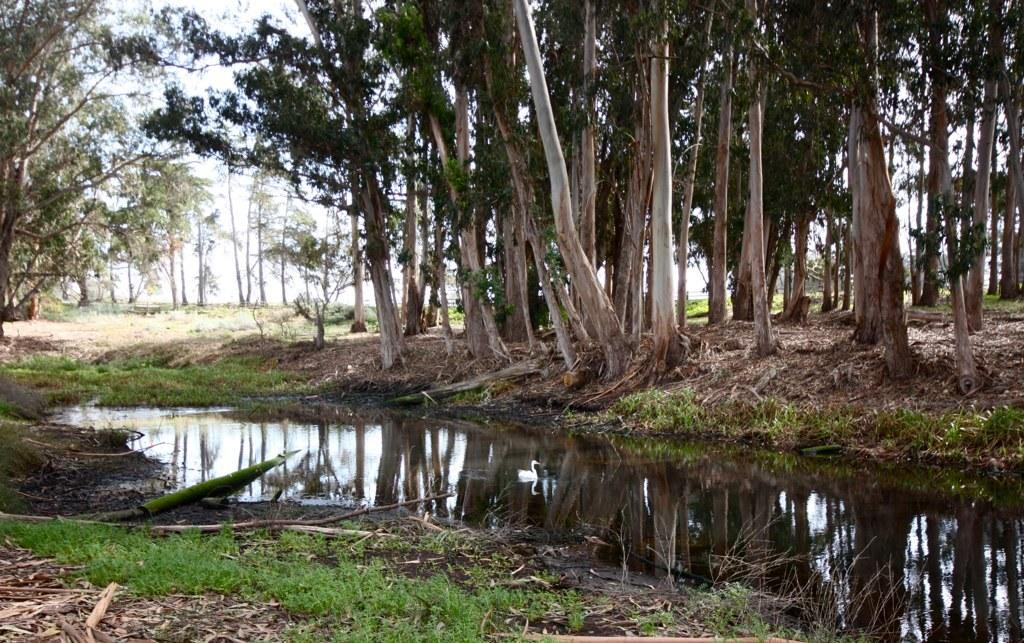What type of vegetation can be seen in the image? There are trees in the image. What is visible at the top of the image? The sky is visible at the top of the image. What animal is present in the image? There is a swan in the image. Is there a reflection of the swan visible in the image? Yes, there is a reflection of a swan on the water in the image. What type of ground surface is present in the image? There is grass in the image. What type of snake can be seen slithering through the grass in the image? There is no snake present in the image; it features trees, the sky, a swan, its reflection, and grass. Can you tell me how many members are in the committee depicted in the image? There is no committee present in the image; it features trees, the sky, a swan, its reflection, and grass. 